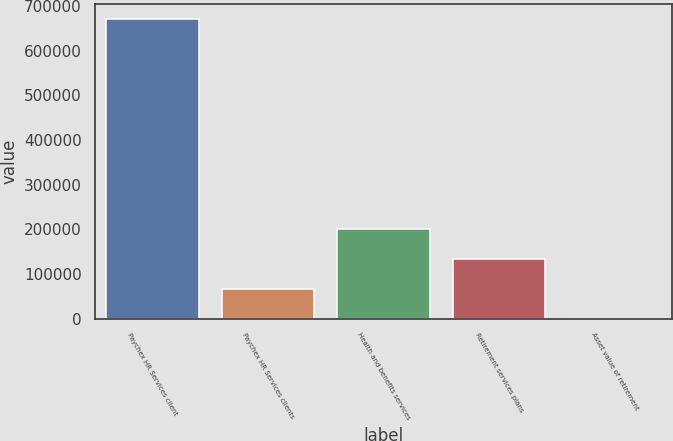Convert chart to OTSL. <chart><loc_0><loc_0><loc_500><loc_500><bar_chart><fcel>Paychex HR Services client<fcel>Paychex HR Services clients<fcel>Health and benefits services<fcel>Retirement services plans<fcel>Asset value of retirement<nl><fcel>672000<fcel>67217.4<fcel>201614<fcel>134415<fcel>19.3<nl></chart> 